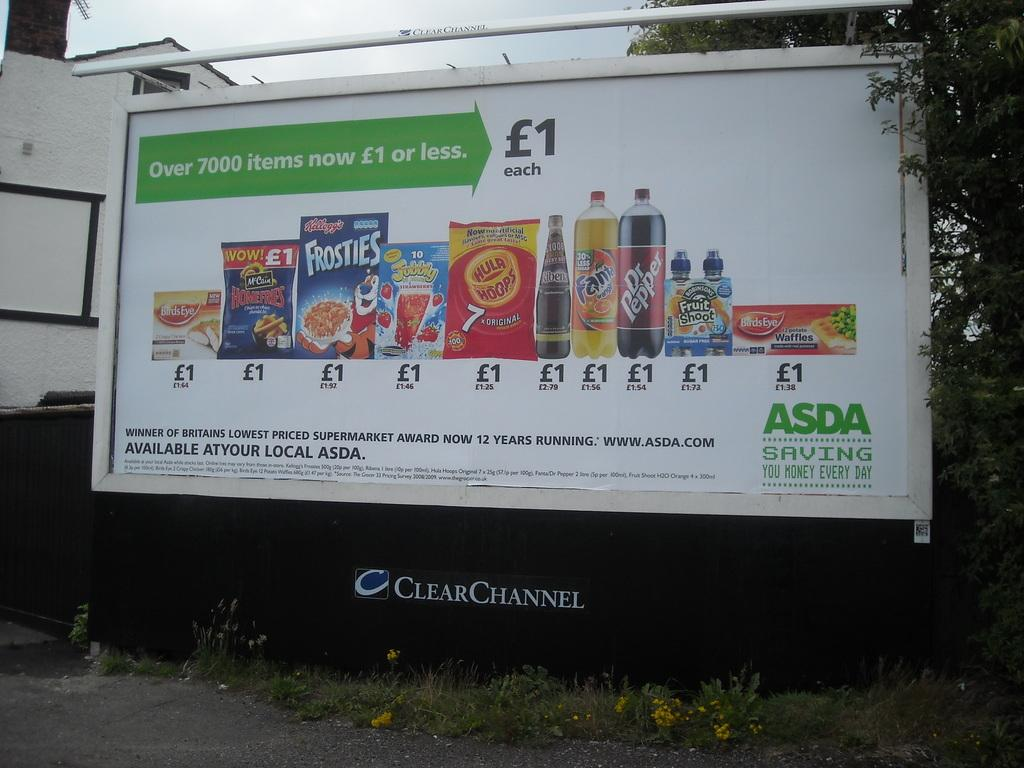<image>
Offer a succinct explanation of the picture presented. a billboard for ASDA displaying common name brand groceries 